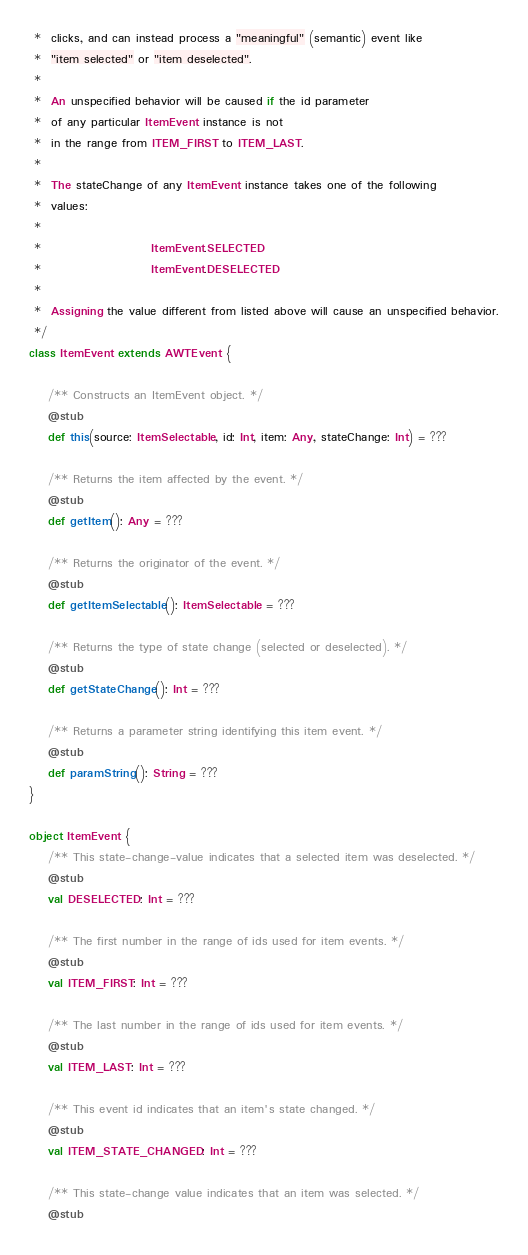Convert code to text. <code><loc_0><loc_0><loc_500><loc_500><_Scala_> *  clicks, and can instead process a "meaningful" (semantic) event like
 *  "item selected" or "item deselected".
 *  
 *  An unspecified behavior will be caused if the id parameter
 *  of any particular ItemEvent instance is not
 *  in the range from ITEM_FIRST to ITEM_LAST.
 *  
 *  The stateChange of any ItemEvent instance takes one of the following
 *  values:
 *                      
 *                       ItemEvent.SELECTED
 *                       ItemEvent.DESELECTED
 *                      
 *  Assigning the value different from listed above will cause an unspecified behavior.
 */
class ItemEvent extends AWTEvent {

    /** Constructs an ItemEvent object. */
    @stub
    def this(source: ItemSelectable, id: Int, item: Any, stateChange: Int) = ???

    /** Returns the item affected by the event. */
    @stub
    def getItem(): Any = ???

    /** Returns the originator of the event. */
    @stub
    def getItemSelectable(): ItemSelectable = ???

    /** Returns the type of state change (selected or deselected). */
    @stub
    def getStateChange(): Int = ???

    /** Returns a parameter string identifying this item event. */
    @stub
    def paramString(): String = ???
}

object ItemEvent {
    /** This state-change-value indicates that a selected item was deselected. */
    @stub
    val DESELECTED: Int = ???

    /** The first number in the range of ids used for item events. */
    @stub
    val ITEM_FIRST: Int = ???

    /** The last number in the range of ids used for item events. */
    @stub
    val ITEM_LAST: Int = ???

    /** This event id indicates that an item's state changed. */
    @stub
    val ITEM_STATE_CHANGED: Int = ???

    /** This state-change value indicates that an item was selected. */
    @stub</code> 